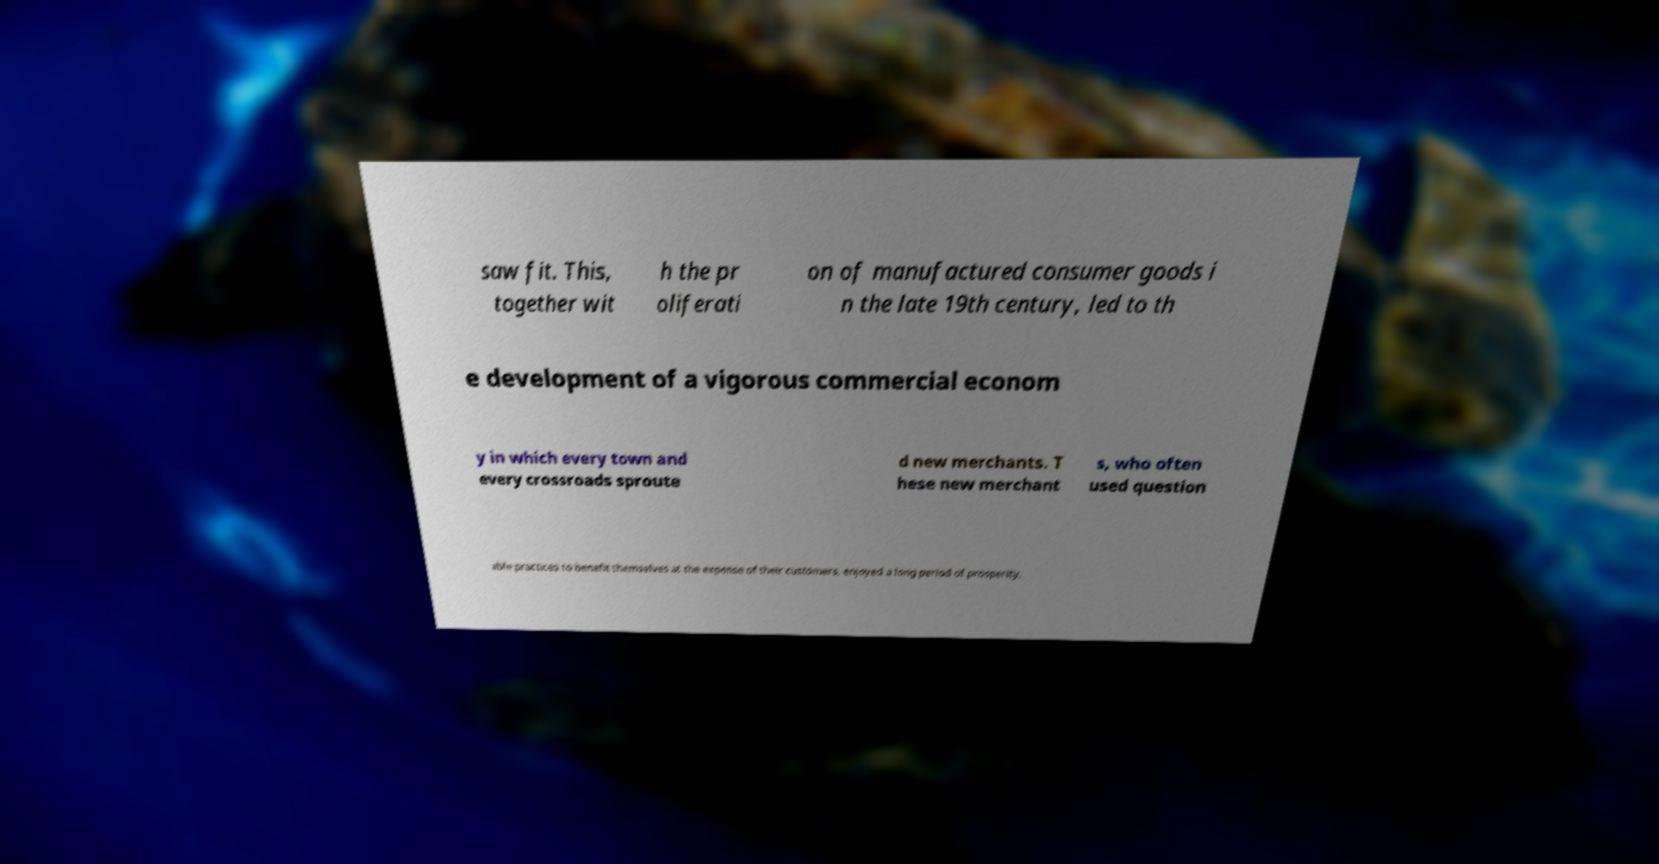What messages or text are displayed in this image? I need them in a readable, typed format. saw fit. This, together wit h the pr oliferati on of manufactured consumer goods i n the late 19th century, led to th e development of a vigorous commercial econom y in which every town and every crossroads sproute d new merchants. T hese new merchant s, who often used question able practices to benefit themselves at the expense of their customers, enjoyed a long period of prosperity. 